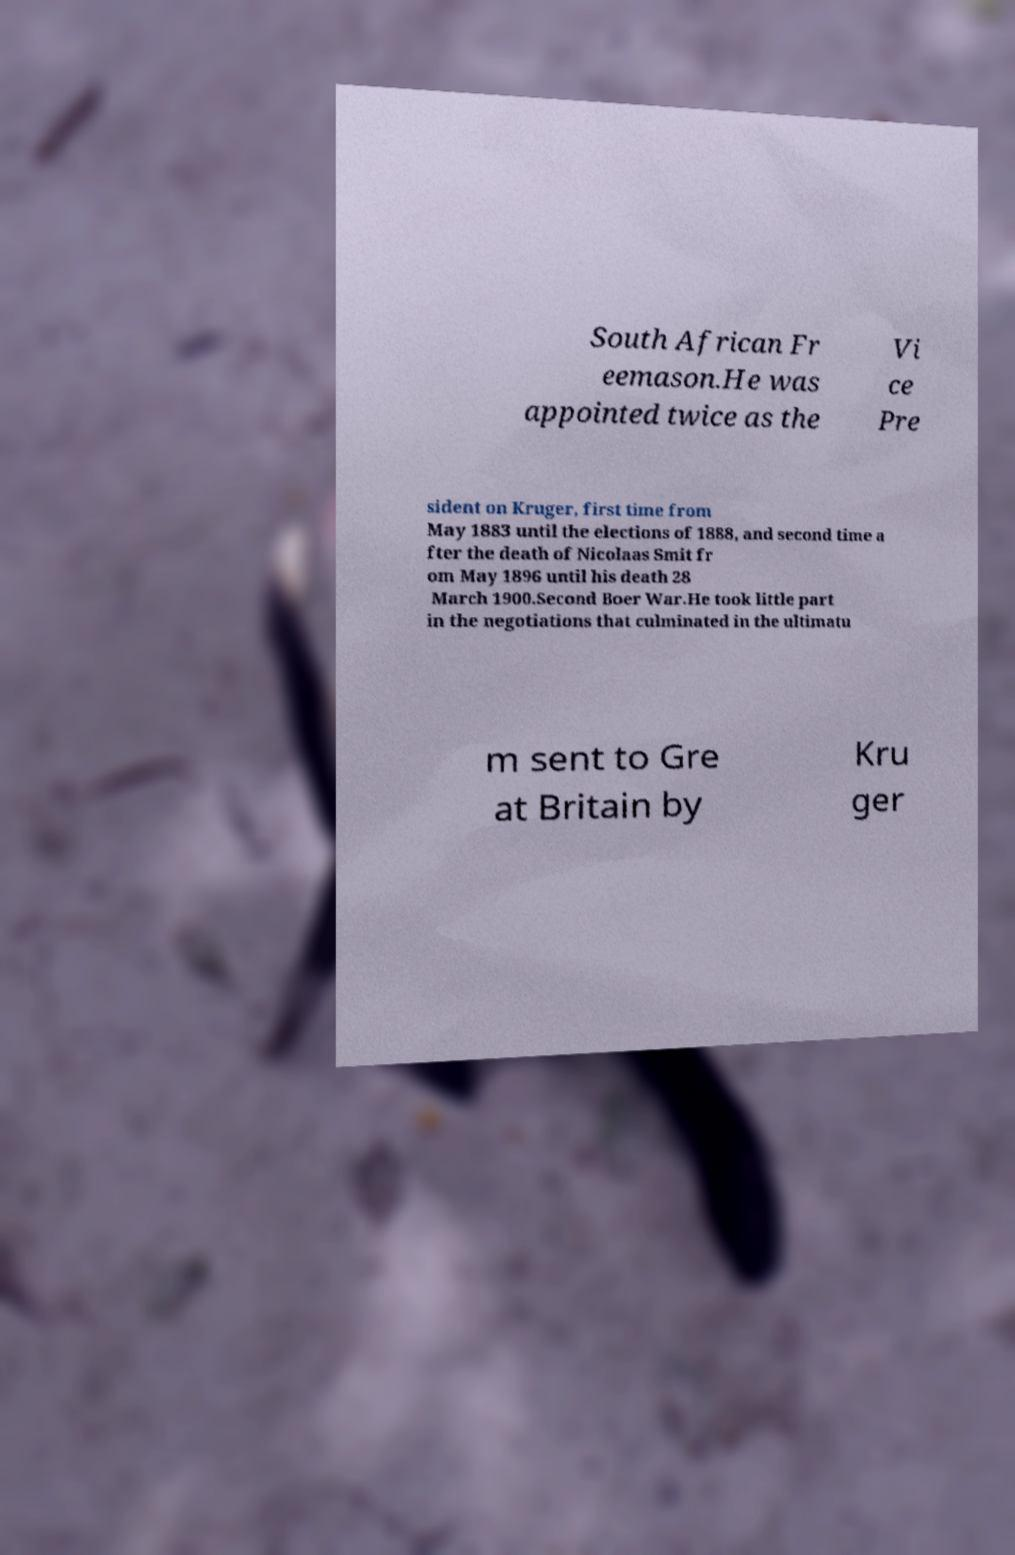What messages or text are displayed in this image? I need them in a readable, typed format. South African Fr eemason.He was appointed twice as the Vi ce Pre sident on Kruger, first time from May 1883 until the elections of 1888, and second time a fter the death of Nicolaas Smit fr om May 1896 until his death 28 March 1900.Second Boer War.He took little part in the negotiations that culminated in the ultimatu m sent to Gre at Britain by Kru ger 